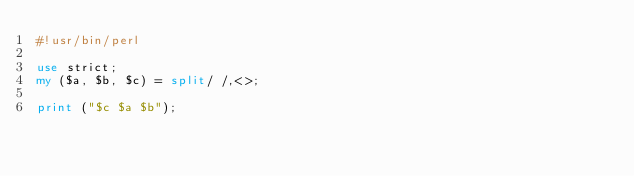Convert code to text. <code><loc_0><loc_0><loc_500><loc_500><_Perl_>#!usr/bin/perl

use strict;
my ($a, $b, $c) = split/ /,<>;

print ("$c $a $b");</code> 